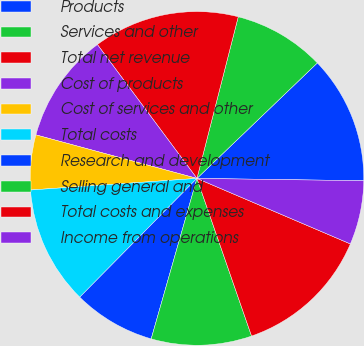Convert chart to OTSL. <chart><loc_0><loc_0><loc_500><loc_500><pie_chart><fcel>Products<fcel>Services and other<fcel>Total net revenue<fcel>Cost of products<fcel>Cost of services and other<fcel>Total costs<fcel>Research and development<fcel>Selling general and<fcel>Total costs and expenses<fcel>Income from operations<nl><fcel>12.39%<fcel>8.85%<fcel>14.16%<fcel>10.62%<fcel>5.31%<fcel>11.5%<fcel>7.97%<fcel>9.73%<fcel>13.27%<fcel>6.2%<nl></chart> 